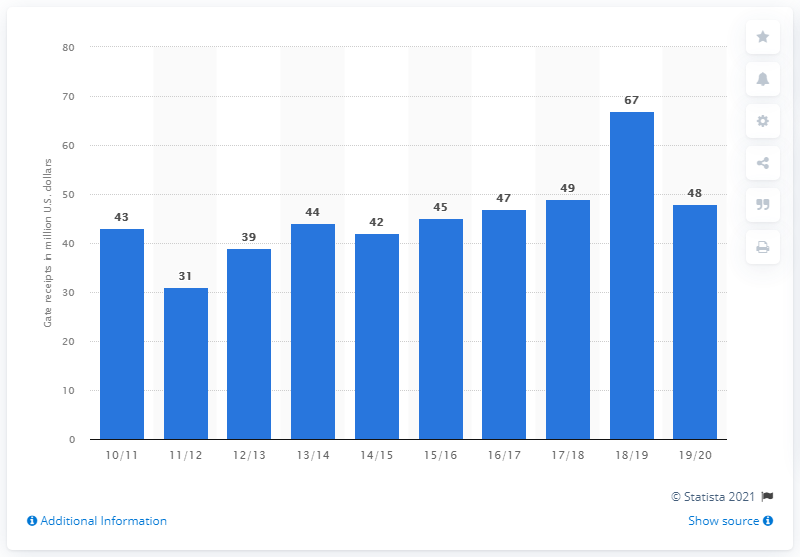Give some essential details in this illustration. The gate receipts of the Portland Trail Blazers in the 2019/20 season were 48 dollars. 